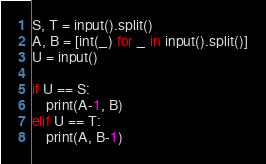Convert code to text. <code><loc_0><loc_0><loc_500><loc_500><_Python_>S, T = input().split()
A, B = [int(_) for _ in input().split()]
U = input()

if U == S:
    print(A-1, B)
elif U == T:
    print(A, B-1)
</code> 